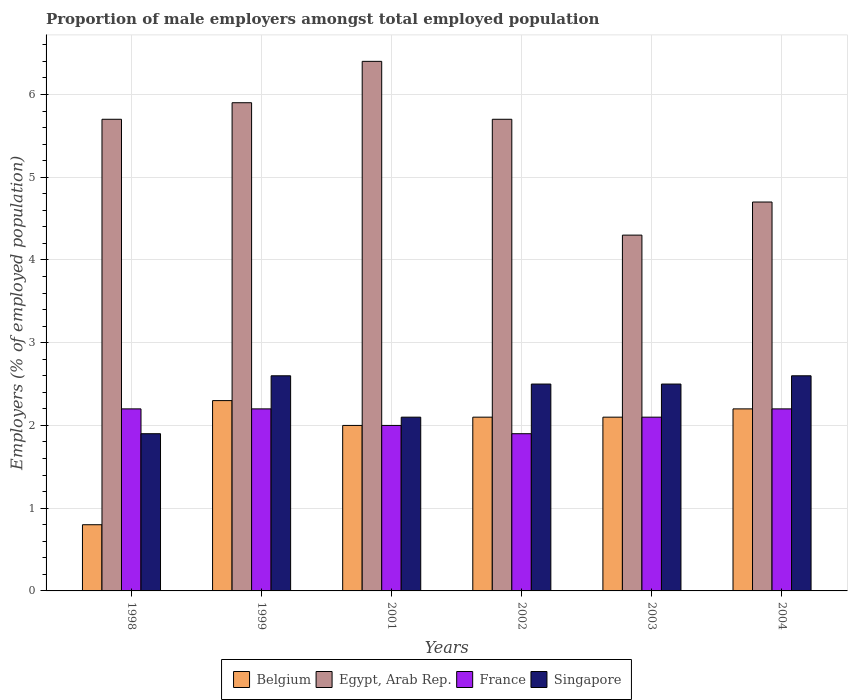How many different coloured bars are there?
Offer a terse response. 4. How many groups of bars are there?
Make the answer very short. 6. Are the number of bars per tick equal to the number of legend labels?
Your answer should be very brief. Yes. How many bars are there on the 3rd tick from the right?
Offer a terse response. 4. What is the label of the 3rd group of bars from the left?
Offer a very short reply. 2001. In how many cases, is the number of bars for a given year not equal to the number of legend labels?
Offer a very short reply. 0. What is the proportion of male employers in Belgium in 1999?
Make the answer very short. 2.3. Across all years, what is the maximum proportion of male employers in France?
Offer a terse response. 2.2. Across all years, what is the minimum proportion of male employers in Egypt, Arab Rep.?
Offer a very short reply. 4.3. In which year was the proportion of male employers in Singapore minimum?
Make the answer very short. 1998. What is the total proportion of male employers in France in the graph?
Provide a short and direct response. 12.6. What is the difference between the proportion of male employers in Singapore in 1999 and that in 2002?
Ensure brevity in your answer.  0.1. What is the difference between the proportion of male employers in Egypt, Arab Rep. in 2001 and the proportion of male employers in Singapore in 2002?
Offer a very short reply. 3.9. What is the average proportion of male employers in France per year?
Keep it short and to the point. 2.1. In the year 1999, what is the difference between the proportion of male employers in Egypt, Arab Rep. and proportion of male employers in France?
Your answer should be very brief. 3.7. Is the proportion of male employers in Egypt, Arab Rep. in 1998 less than that in 2004?
Provide a short and direct response. No. What is the difference between the highest and the second highest proportion of male employers in Egypt, Arab Rep.?
Offer a terse response. 0.5. What is the difference between the highest and the lowest proportion of male employers in Belgium?
Offer a very short reply. 1.5. Is the sum of the proportion of male employers in Egypt, Arab Rep. in 2001 and 2002 greater than the maximum proportion of male employers in Singapore across all years?
Your answer should be compact. Yes. What does the 4th bar from the right in 2001 represents?
Provide a short and direct response. Belgium. How many bars are there?
Keep it short and to the point. 24. What is the difference between two consecutive major ticks on the Y-axis?
Your answer should be compact. 1. Are the values on the major ticks of Y-axis written in scientific E-notation?
Give a very brief answer. No. Does the graph contain any zero values?
Your answer should be very brief. No. Where does the legend appear in the graph?
Make the answer very short. Bottom center. What is the title of the graph?
Keep it short and to the point. Proportion of male employers amongst total employed population. What is the label or title of the X-axis?
Ensure brevity in your answer.  Years. What is the label or title of the Y-axis?
Keep it short and to the point. Employers (% of employed population). What is the Employers (% of employed population) in Belgium in 1998?
Your response must be concise. 0.8. What is the Employers (% of employed population) in Egypt, Arab Rep. in 1998?
Offer a very short reply. 5.7. What is the Employers (% of employed population) in France in 1998?
Offer a terse response. 2.2. What is the Employers (% of employed population) of Singapore in 1998?
Your answer should be compact. 1.9. What is the Employers (% of employed population) in Belgium in 1999?
Offer a terse response. 2.3. What is the Employers (% of employed population) in Egypt, Arab Rep. in 1999?
Give a very brief answer. 5.9. What is the Employers (% of employed population) in France in 1999?
Keep it short and to the point. 2.2. What is the Employers (% of employed population) of Singapore in 1999?
Keep it short and to the point. 2.6. What is the Employers (% of employed population) of Egypt, Arab Rep. in 2001?
Give a very brief answer. 6.4. What is the Employers (% of employed population) in France in 2001?
Provide a short and direct response. 2. What is the Employers (% of employed population) of Singapore in 2001?
Ensure brevity in your answer.  2.1. What is the Employers (% of employed population) of Belgium in 2002?
Your response must be concise. 2.1. What is the Employers (% of employed population) of Egypt, Arab Rep. in 2002?
Give a very brief answer. 5.7. What is the Employers (% of employed population) of France in 2002?
Your answer should be very brief. 1.9. What is the Employers (% of employed population) in Singapore in 2002?
Make the answer very short. 2.5. What is the Employers (% of employed population) in Belgium in 2003?
Ensure brevity in your answer.  2.1. What is the Employers (% of employed population) of Egypt, Arab Rep. in 2003?
Keep it short and to the point. 4.3. What is the Employers (% of employed population) of France in 2003?
Make the answer very short. 2.1. What is the Employers (% of employed population) in Singapore in 2003?
Ensure brevity in your answer.  2.5. What is the Employers (% of employed population) of Belgium in 2004?
Ensure brevity in your answer.  2.2. What is the Employers (% of employed population) of Egypt, Arab Rep. in 2004?
Offer a terse response. 4.7. What is the Employers (% of employed population) in France in 2004?
Provide a succinct answer. 2.2. What is the Employers (% of employed population) in Singapore in 2004?
Offer a very short reply. 2.6. Across all years, what is the maximum Employers (% of employed population) of Belgium?
Provide a succinct answer. 2.3. Across all years, what is the maximum Employers (% of employed population) in Egypt, Arab Rep.?
Offer a terse response. 6.4. Across all years, what is the maximum Employers (% of employed population) in France?
Your answer should be compact. 2.2. Across all years, what is the maximum Employers (% of employed population) in Singapore?
Ensure brevity in your answer.  2.6. Across all years, what is the minimum Employers (% of employed population) of Belgium?
Give a very brief answer. 0.8. Across all years, what is the minimum Employers (% of employed population) of Egypt, Arab Rep.?
Your response must be concise. 4.3. Across all years, what is the minimum Employers (% of employed population) of France?
Provide a succinct answer. 1.9. Across all years, what is the minimum Employers (% of employed population) of Singapore?
Provide a succinct answer. 1.9. What is the total Employers (% of employed population) of Egypt, Arab Rep. in the graph?
Your answer should be compact. 32.7. What is the total Employers (% of employed population) in Singapore in the graph?
Offer a very short reply. 14.2. What is the difference between the Employers (% of employed population) in Belgium in 1998 and that in 1999?
Ensure brevity in your answer.  -1.5. What is the difference between the Employers (% of employed population) in Egypt, Arab Rep. in 1998 and that in 1999?
Your answer should be compact. -0.2. What is the difference between the Employers (% of employed population) of France in 1998 and that in 1999?
Your response must be concise. 0. What is the difference between the Employers (% of employed population) in Singapore in 1998 and that in 1999?
Give a very brief answer. -0.7. What is the difference between the Employers (% of employed population) in France in 1998 and that in 2001?
Give a very brief answer. 0.2. What is the difference between the Employers (% of employed population) in Singapore in 1998 and that in 2001?
Keep it short and to the point. -0.2. What is the difference between the Employers (% of employed population) in Egypt, Arab Rep. in 1998 and that in 2003?
Keep it short and to the point. 1.4. What is the difference between the Employers (% of employed population) of Singapore in 1998 and that in 2003?
Offer a terse response. -0.6. What is the difference between the Employers (% of employed population) in Belgium in 1998 and that in 2004?
Provide a short and direct response. -1.4. What is the difference between the Employers (% of employed population) of Belgium in 1999 and that in 2001?
Give a very brief answer. 0.3. What is the difference between the Employers (% of employed population) in France in 1999 and that in 2001?
Give a very brief answer. 0.2. What is the difference between the Employers (% of employed population) in Singapore in 1999 and that in 2001?
Your response must be concise. 0.5. What is the difference between the Employers (% of employed population) of Belgium in 1999 and that in 2002?
Your answer should be compact. 0.2. What is the difference between the Employers (% of employed population) of Belgium in 1999 and that in 2003?
Your answer should be compact. 0.2. What is the difference between the Employers (% of employed population) of France in 1999 and that in 2003?
Give a very brief answer. 0.1. What is the difference between the Employers (% of employed population) of Singapore in 1999 and that in 2003?
Offer a very short reply. 0.1. What is the difference between the Employers (% of employed population) of Belgium in 1999 and that in 2004?
Your response must be concise. 0.1. What is the difference between the Employers (% of employed population) of Egypt, Arab Rep. in 1999 and that in 2004?
Provide a short and direct response. 1.2. What is the difference between the Employers (% of employed population) in Singapore in 1999 and that in 2004?
Your response must be concise. 0. What is the difference between the Employers (% of employed population) of Singapore in 2001 and that in 2002?
Keep it short and to the point. -0.4. What is the difference between the Employers (% of employed population) of Egypt, Arab Rep. in 2001 and that in 2003?
Offer a very short reply. 2.1. What is the difference between the Employers (% of employed population) in France in 2001 and that in 2003?
Ensure brevity in your answer.  -0.1. What is the difference between the Employers (% of employed population) in Belgium in 2001 and that in 2004?
Offer a terse response. -0.2. What is the difference between the Employers (% of employed population) of Egypt, Arab Rep. in 2001 and that in 2004?
Provide a succinct answer. 1.7. What is the difference between the Employers (% of employed population) of France in 2001 and that in 2004?
Offer a terse response. -0.2. What is the difference between the Employers (% of employed population) in Egypt, Arab Rep. in 2002 and that in 2003?
Give a very brief answer. 1.4. What is the difference between the Employers (% of employed population) in Singapore in 2002 and that in 2004?
Offer a very short reply. -0.1. What is the difference between the Employers (% of employed population) of Belgium in 2003 and that in 2004?
Make the answer very short. -0.1. What is the difference between the Employers (% of employed population) of Singapore in 2003 and that in 2004?
Your response must be concise. -0.1. What is the difference between the Employers (% of employed population) of Belgium in 1998 and the Employers (% of employed population) of Singapore in 1999?
Provide a succinct answer. -1.8. What is the difference between the Employers (% of employed population) in Egypt, Arab Rep. in 1998 and the Employers (% of employed population) in Singapore in 1999?
Make the answer very short. 3.1. What is the difference between the Employers (% of employed population) of Belgium in 1998 and the Employers (% of employed population) of Egypt, Arab Rep. in 2001?
Give a very brief answer. -5.6. What is the difference between the Employers (% of employed population) in France in 1998 and the Employers (% of employed population) in Singapore in 2001?
Make the answer very short. 0.1. What is the difference between the Employers (% of employed population) in Belgium in 1998 and the Employers (% of employed population) in France in 2002?
Offer a very short reply. -1.1. What is the difference between the Employers (% of employed population) in Belgium in 1998 and the Employers (% of employed population) in Singapore in 2002?
Offer a very short reply. -1.7. What is the difference between the Employers (% of employed population) of Egypt, Arab Rep. in 1998 and the Employers (% of employed population) of France in 2002?
Make the answer very short. 3.8. What is the difference between the Employers (% of employed population) of France in 1998 and the Employers (% of employed population) of Singapore in 2002?
Your response must be concise. -0.3. What is the difference between the Employers (% of employed population) in Belgium in 1998 and the Employers (% of employed population) in Egypt, Arab Rep. in 2003?
Make the answer very short. -3.5. What is the difference between the Employers (% of employed population) in Belgium in 1998 and the Employers (% of employed population) in Singapore in 2003?
Your response must be concise. -1.7. What is the difference between the Employers (% of employed population) of Egypt, Arab Rep. in 1998 and the Employers (% of employed population) of France in 2003?
Give a very brief answer. 3.6. What is the difference between the Employers (% of employed population) in France in 1998 and the Employers (% of employed population) in Singapore in 2003?
Keep it short and to the point. -0.3. What is the difference between the Employers (% of employed population) in Belgium in 1998 and the Employers (% of employed population) in Egypt, Arab Rep. in 2004?
Your response must be concise. -3.9. What is the difference between the Employers (% of employed population) of Belgium in 1998 and the Employers (% of employed population) of France in 2004?
Provide a short and direct response. -1.4. What is the difference between the Employers (% of employed population) in Egypt, Arab Rep. in 1998 and the Employers (% of employed population) in Singapore in 2004?
Ensure brevity in your answer.  3.1. What is the difference between the Employers (% of employed population) in France in 1998 and the Employers (% of employed population) in Singapore in 2004?
Your response must be concise. -0.4. What is the difference between the Employers (% of employed population) of Belgium in 1999 and the Employers (% of employed population) of Egypt, Arab Rep. in 2001?
Your answer should be compact. -4.1. What is the difference between the Employers (% of employed population) of Egypt, Arab Rep. in 1999 and the Employers (% of employed population) of France in 2001?
Your response must be concise. 3.9. What is the difference between the Employers (% of employed population) in France in 1999 and the Employers (% of employed population) in Singapore in 2001?
Make the answer very short. 0.1. What is the difference between the Employers (% of employed population) of Belgium in 1999 and the Employers (% of employed population) of Egypt, Arab Rep. in 2002?
Your answer should be compact. -3.4. What is the difference between the Employers (% of employed population) of Belgium in 1999 and the Employers (% of employed population) of Singapore in 2002?
Provide a short and direct response. -0.2. What is the difference between the Employers (% of employed population) of Belgium in 1999 and the Employers (% of employed population) of Singapore in 2003?
Make the answer very short. -0.2. What is the difference between the Employers (% of employed population) of France in 1999 and the Employers (% of employed population) of Singapore in 2003?
Provide a short and direct response. -0.3. What is the difference between the Employers (% of employed population) of Belgium in 1999 and the Employers (% of employed population) of Singapore in 2004?
Give a very brief answer. -0.3. What is the difference between the Employers (% of employed population) in France in 1999 and the Employers (% of employed population) in Singapore in 2004?
Your answer should be compact. -0.4. What is the difference between the Employers (% of employed population) of Belgium in 2001 and the Employers (% of employed population) of Egypt, Arab Rep. in 2002?
Provide a short and direct response. -3.7. What is the difference between the Employers (% of employed population) of Belgium in 2001 and the Employers (% of employed population) of Singapore in 2002?
Offer a very short reply. -0.5. What is the difference between the Employers (% of employed population) in Egypt, Arab Rep. in 2001 and the Employers (% of employed population) in France in 2002?
Make the answer very short. 4.5. What is the difference between the Employers (% of employed population) in Egypt, Arab Rep. in 2001 and the Employers (% of employed population) in Singapore in 2002?
Offer a terse response. 3.9. What is the difference between the Employers (% of employed population) of France in 2001 and the Employers (% of employed population) of Singapore in 2003?
Provide a succinct answer. -0.5. What is the difference between the Employers (% of employed population) in Belgium in 2001 and the Employers (% of employed population) in Egypt, Arab Rep. in 2004?
Offer a terse response. -2.7. What is the difference between the Employers (% of employed population) in Belgium in 2001 and the Employers (% of employed population) in Singapore in 2004?
Your answer should be very brief. -0.6. What is the difference between the Employers (% of employed population) in Egypt, Arab Rep. in 2001 and the Employers (% of employed population) in Singapore in 2004?
Offer a very short reply. 3.8. What is the difference between the Employers (% of employed population) in Belgium in 2002 and the Employers (% of employed population) in Egypt, Arab Rep. in 2003?
Provide a succinct answer. -2.2. What is the difference between the Employers (% of employed population) of Egypt, Arab Rep. in 2002 and the Employers (% of employed population) of Singapore in 2003?
Your response must be concise. 3.2. What is the difference between the Employers (% of employed population) of France in 2002 and the Employers (% of employed population) of Singapore in 2003?
Your answer should be very brief. -0.6. What is the difference between the Employers (% of employed population) of Belgium in 2002 and the Employers (% of employed population) of Singapore in 2004?
Offer a terse response. -0.5. What is the difference between the Employers (% of employed population) in Egypt, Arab Rep. in 2002 and the Employers (% of employed population) in Singapore in 2004?
Provide a succinct answer. 3.1. What is the difference between the Employers (% of employed population) in France in 2002 and the Employers (% of employed population) in Singapore in 2004?
Make the answer very short. -0.7. What is the difference between the Employers (% of employed population) of Belgium in 2003 and the Employers (% of employed population) of Egypt, Arab Rep. in 2004?
Offer a terse response. -2.6. What is the difference between the Employers (% of employed population) in Belgium in 2003 and the Employers (% of employed population) in France in 2004?
Provide a short and direct response. -0.1. What is the difference between the Employers (% of employed population) of Belgium in 2003 and the Employers (% of employed population) of Singapore in 2004?
Give a very brief answer. -0.5. What is the difference between the Employers (% of employed population) in Egypt, Arab Rep. in 2003 and the Employers (% of employed population) in Singapore in 2004?
Ensure brevity in your answer.  1.7. What is the difference between the Employers (% of employed population) of France in 2003 and the Employers (% of employed population) of Singapore in 2004?
Make the answer very short. -0.5. What is the average Employers (% of employed population) of Belgium per year?
Offer a very short reply. 1.92. What is the average Employers (% of employed population) of Egypt, Arab Rep. per year?
Keep it short and to the point. 5.45. What is the average Employers (% of employed population) in Singapore per year?
Offer a terse response. 2.37. In the year 1998, what is the difference between the Employers (% of employed population) in Egypt, Arab Rep. and Employers (% of employed population) in France?
Make the answer very short. 3.5. In the year 1998, what is the difference between the Employers (% of employed population) of Egypt, Arab Rep. and Employers (% of employed population) of Singapore?
Give a very brief answer. 3.8. In the year 1998, what is the difference between the Employers (% of employed population) in France and Employers (% of employed population) in Singapore?
Ensure brevity in your answer.  0.3. In the year 1999, what is the difference between the Employers (% of employed population) of Egypt, Arab Rep. and Employers (% of employed population) of Singapore?
Make the answer very short. 3.3. In the year 2002, what is the difference between the Employers (% of employed population) in Belgium and Employers (% of employed population) in France?
Offer a very short reply. 0.2. In the year 2002, what is the difference between the Employers (% of employed population) of Egypt, Arab Rep. and Employers (% of employed population) of France?
Ensure brevity in your answer.  3.8. In the year 2003, what is the difference between the Employers (% of employed population) of Belgium and Employers (% of employed population) of France?
Your answer should be compact. 0. In the year 2003, what is the difference between the Employers (% of employed population) in Egypt, Arab Rep. and Employers (% of employed population) in Singapore?
Give a very brief answer. 1.8. What is the ratio of the Employers (% of employed population) in Belgium in 1998 to that in 1999?
Provide a short and direct response. 0.35. What is the ratio of the Employers (% of employed population) in Egypt, Arab Rep. in 1998 to that in 1999?
Give a very brief answer. 0.97. What is the ratio of the Employers (% of employed population) of Singapore in 1998 to that in 1999?
Provide a succinct answer. 0.73. What is the ratio of the Employers (% of employed population) of Egypt, Arab Rep. in 1998 to that in 2001?
Your answer should be very brief. 0.89. What is the ratio of the Employers (% of employed population) of France in 1998 to that in 2001?
Keep it short and to the point. 1.1. What is the ratio of the Employers (% of employed population) of Singapore in 1998 to that in 2001?
Provide a short and direct response. 0.9. What is the ratio of the Employers (% of employed population) in Belgium in 1998 to that in 2002?
Your response must be concise. 0.38. What is the ratio of the Employers (% of employed population) in France in 1998 to that in 2002?
Ensure brevity in your answer.  1.16. What is the ratio of the Employers (% of employed population) of Singapore in 1998 to that in 2002?
Your answer should be very brief. 0.76. What is the ratio of the Employers (% of employed population) of Belgium in 1998 to that in 2003?
Provide a short and direct response. 0.38. What is the ratio of the Employers (% of employed population) in Egypt, Arab Rep. in 1998 to that in 2003?
Ensure brevity in your answer.  1.33. What is the ratio of the Employers (% of employed population) of France in 1998 to that in 2003?
Make the answer very short. 1.05. What is the ratio of the Employers (% of employed population) in Singapore in 1998 to that in 2003?
Keep it short and to the point. 0.76. What is the ratio of the Employers (% of employed population) of Belgium in 1998 to that in 2004?
Offer a very short reply. 0.36. What is the ratio of the Employers (% of employed population) of Egypt, Arab Rep. in 1998 to that in 2004?
Ensure brevity in your answer.  1.21. What is the ratio of the Employers (% of employed population) in France in 1998 to that in 2004?
Make the answer very short. 1. What is the ratio of the Employers (% of employed population) in Singapore in 1998 to that in 2004?
Provide a short and direct response. 0.73. What is the ratio of the Employers (% of employed population) in Belgium in 1999 to that in 2001?
Give a very brief answer. 1.15. What is the ratio of the Employers (% of employed population) in Egypt, Arab Rep. in 1999 to that in 2001?
Your answer should be compact. 0.92. What is the ratio of the Employers (% of employed population) in France in 1999 to that in 2001?
Your response must be concise. 1.1. What is the ratio of the Employers (% of employed population) in Singapore in 1999 to that in 2001?
Your answer should be compact. 1.24. What is the ratio of the Employers (% of employed population) in Belgium in 1999 to that in 2002?
Ensure brevity in your answer.  1.1. What is the ratio of the Employers (% of employed population) in Egypt, Arab Rep. in 1999 to that in 2002?
Make the answer very short. 1.04. What is the ratio of the Employers (% of employed population) of France in 1999 to that in 2002?
Your answer should be very brief. 1.16. What is the ratio of the Employers (% of employed population) of Singapore in 1999 to that in 2002?
Ensure brevity in your answer.  1.04. What is the ratio of the Employers (% of employed population) in Belgium in 1999 to that in 2003?
Your answer should be compact. 1.1. What is the ratio of the Employers (% of employed population) of Egypt, Arab Rep. in 1999 to that in 2003?
Provide a succinct answer. 1.37. What is the ratio of the Employers (% of employed population) in France in 1999 to that in 2003?
Provide a succinct answer. 1.05. What is the ratio of the Employers (% of employed population) in Belgium in 1999 to that in 2004?
Provide a succinct answer. 1.05. What is the ratio of the Employers (% of employed population) of Egypt, Arab Rep. in 1999 to that in 2004?
Offer a very short reply. 1.26. What is the ratio of the Employers (% of employed population) in France in 1999 to that in 2004?
Make the answer very short. 1. What is the ratio of the Employers (% of employed population) in Belgium in 2001 to that in 2002?
Your answer should be very brief. 0.95. What is the ratio of the Employers (% of employed population) in Egypt, Arab Rep. in 2001 to that in 2002?
Offer a terse response. 1.12. What is the ratio of the Employers (% of employed population) of France in 2001 to that in 2002?
Provide a succinct answer. 1.05. What is the ratio of the Employers (% of employed population) in Singapore in 2001 to that in 2002?
Keep it short and to the point. 0.84. What is the ratio of the Employers (% of employed population) in Egypt, Arab Rep. in 2001 to that in 2003?
Offer a very short reply. 1.49. What is the ratio of the Employers (% of employed population) of Singapore in 2001 to that in 2003?
Offer a very short reply. 0.84. What is the ratio of the Employers (% of employed population) of Belgium in 2001 to that in 2004?
Give a very brief answer. 0.91. What is the ratio of the Employers (% of employed population) of Egypt, Arab Rep. in 2001 to that in 2004?
Ensure brevity in your answer.  1.36. What is the ratio of the Employers (% of employed population) in Singapore in 2001 to that in 2004?
Keep it short and to the point. 0.81. What is the ratio of the Employers (% of employed population) in Belgium in 2002 to that in 2003?
Offer a terse response. 1. What is the ratio of the Employers (% of employed population) in Egypt, Arab Rep. in 2002 to that in 2003?
Keep it short and to the point. 1.33. What is the ratio of the Employers (% of employed population) of France in 2002 to that in 2003?
Provide a succinct answer. 0.9. What is the ratio of the Employers (% of employed population) of Belgium in 2002 to that in 2004?
Make the answer very short. 0.95. What is the ratio of the Employers (% of employed population) of Egypt, Arab Rep. in 2002 to that in 2004?
Keep it short and to the point. 1.21. What is the ratio of the Employers (% of employed population) in France in 2002 to that in 2004?
Ensure brevity in your answer.  0.86. What is the ratio of the Employers (% of employed population) of Singapore in 2002 to that in 2004?
Provide a succinct answer. 0.96. What is the ratio of the Employers (% of employed population) in Belgium in 2003 to that in 2004?
Offer a terse response. 0.95. What is the ratio of the Employers (% of employed population) of Egypt, Arab Rep. in 2003 to that in 2004?
Keep it short and to the point. 0.91. What is the ratio of the Employers (% of employed population) of France in 2003 to that in 2004?
Make the answer very short. 0.95. What is the ratio of the Employers (% of employed population) of Singapore in 2003 to that in 2004?
Ensure brevity in your answer.  0.96. What is the difference between the highest and the second highest Employers (% of employed population) in France?
Keep it short and to the point. 0. What is the difference between the highest and the lowest Employers (% of employed population) of Belgium?
Provide a succinct answer. 1.5. What is the difference between the highest and the lowest Employers (% of employed population) in France?
Ensure brevity in your answer.  0.3. 